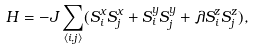Convert formula to latex. <formula><loc_0><loc_0><loc_500><loc_500>H = - J \sum _ { \langle i , j \rangle } ( S _ { i } ^ { x } S _ { j } ^ { x } + S _ { i } ^ { y } S _ { j } ^ { y } + \lambda S _ { i } ^ { z } S _ { j } ^ { z } ) ,</formula> 